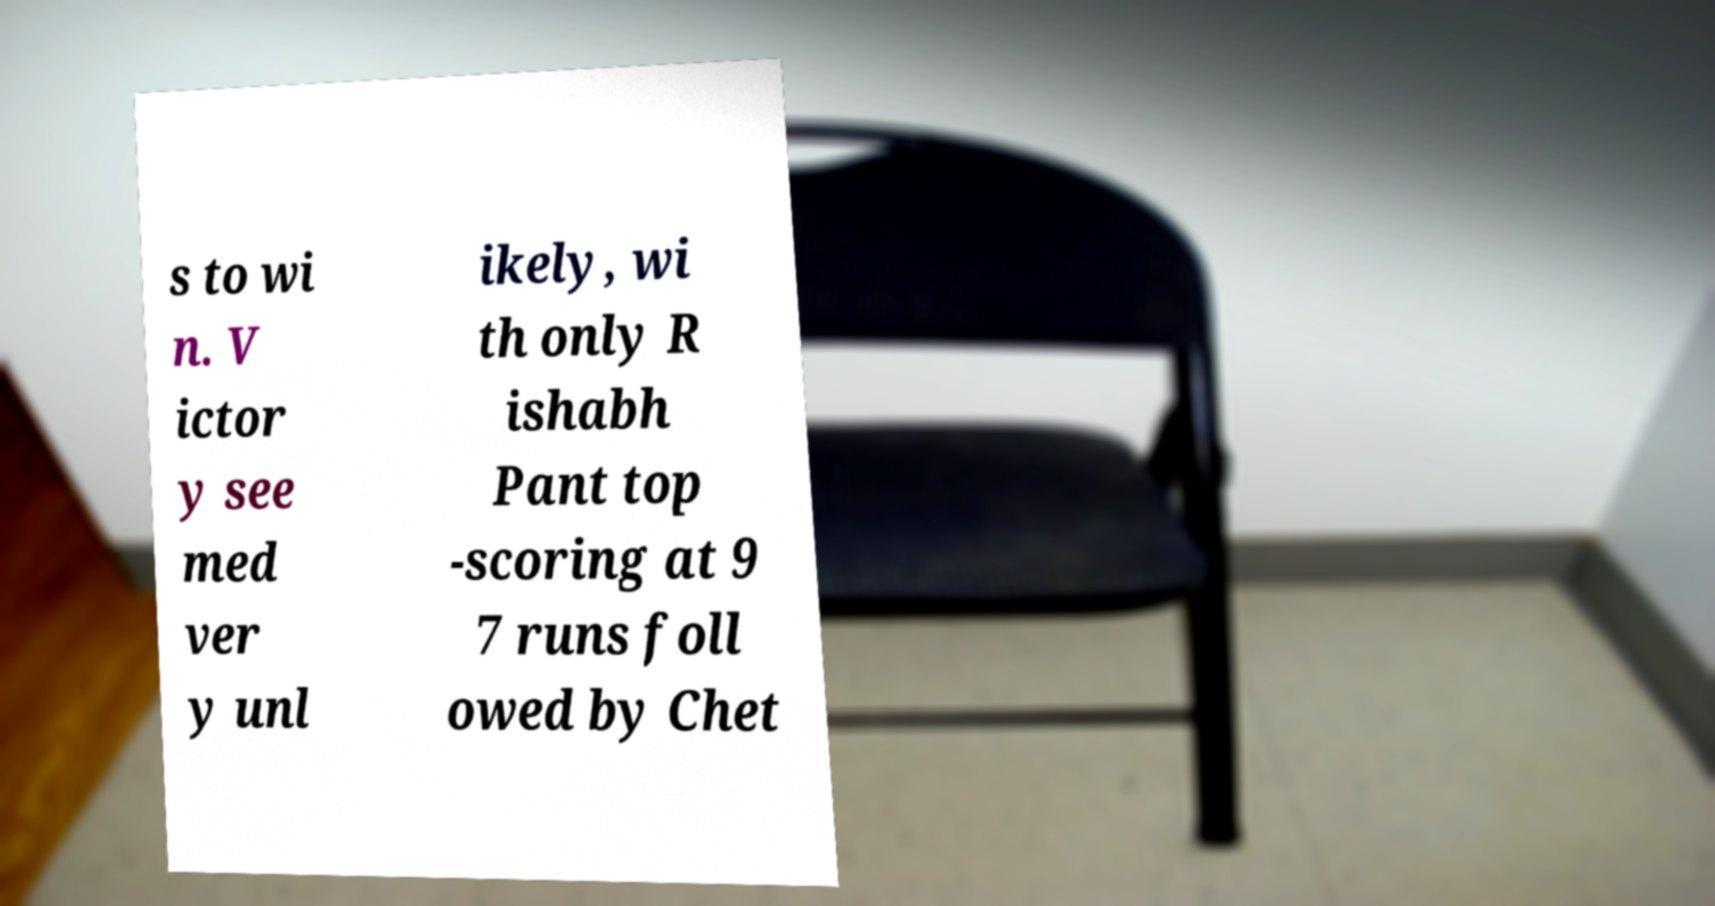Please identify and transcribe the text found in this image. s to wi n. V ictor y see med ver y unl ikely, wi th only R ishabh Pant top -scoring at 9 7 runs foll owed by Chet 